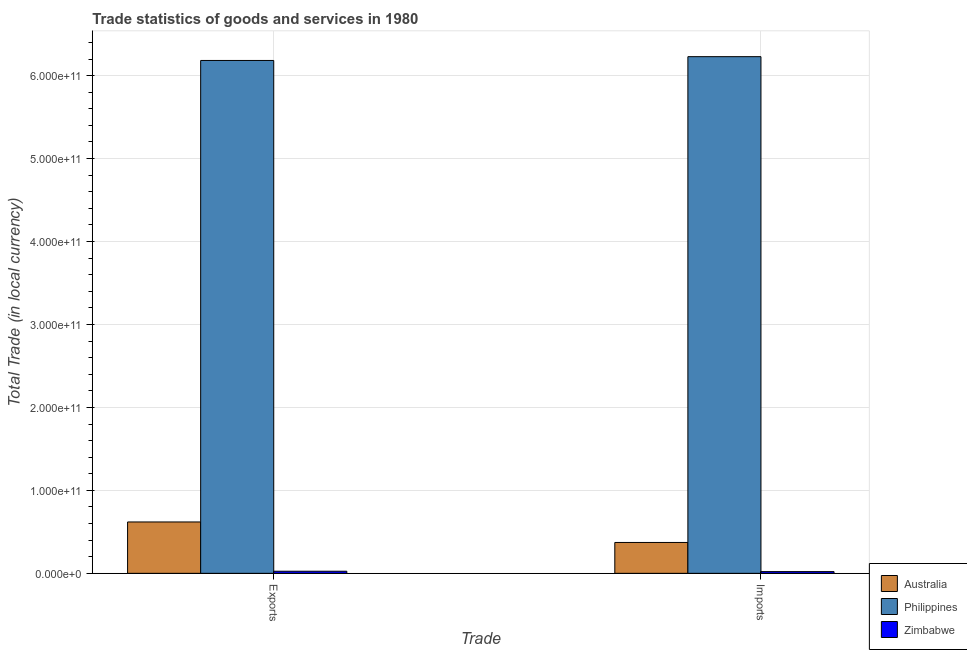How many different coloured bars are there?
Your response must be concise. 3. Are the number of bars per tick equal to the number of legend labels?
Offer a very short reply. Yes. What is the label of the 2nd group of bars from the left?
Make the answer very short. Imports. What is the export of goods and services in Australia?
Make the answer very short. 6.19e+1. Across all countries, what is the maximum imports of goods and services?
Offer a terse response. 6.23e+11. Across all countries, what is the minimum imports of goods and services?
Your answer should be compact. 2.06e+09. In which country was the imports of goods and services minimum?
Ensure brevity in your answer.  Zimbabwe. What is the total export of goods and services in the graph?
Your response must be concise. 6.83e+11. What is the difference between the imports of goods and services in Philippines and that in Zimbabwe?
Ensure brevity in your answer.  6.21e+11. What is the difference between the imports of goods and services in Philippines and the export of goods and services in Australia?
Provide a short and direct response. 5.61e+11. What is the average imports of goods and services per country?
Your response must be concise. 2.21e+11. What is the difference between the export of goods and services and imports of goods and services in Philippines?
Keep it short and to the point. -4.58e+09. What is the ratio of the imports of goods and services in Australia to that in Philippines?
Ensure brevity in your answer.  0.06. What does the 2nd bar from the right in Exports represents?
Your answer should be compact. Philippines. How many bars are there?
Make the answer very short. 6. What is the difference between two consecutive major ticks on the Y-axis?
Make the answer very short. 1.00e+11. Are the values on the major ticks of Y-axis written in scientific E-notation?
Keep it short and to the point. Yes. Does the graph contain any zero values?
Provide a short and direct response. No. Where does the legend appear in the graph?
Ensure brevity in your answer.  Bottom right. How many legend labels are there?
Provide a succinct answer. 3. What is the title of the graph?
Your response must be concise. Trade statistics of goods and services in 1980. Does "Iran" appear as one of the legend labels in the graph?
Offer a terse response. No. What is the label or title of the X-axis?
Ensure brevity in your answer.  Trade. What is the label or title of the Y-axis?
Make the answer very short. Total Trade (in local currency). What is the Total Trade (in local currency) in Australia in Exports?
Offer a terse response. 6.19e+1. What is the Total Trade (in local currency) of Philippines in Exports?
Provide a short and direct response. 6.18e+11. What is the Total Trade (in local currency) in Zimbabwe in Exports?
Provide a succinct answer. 2.54e+09. What is the Total Trade (in local currency) in Australia in Imports?
Your response must be concise. 3.72e+1. What is the Total Trade (in local currency) in Philippines in Imports?
Ensure brevity in your answer.  6.23e+11. What is the Total Trade (in local currency) in Zimbabwe in Imports?
Give a very brief answer. 2.06e+09. Across all Trade, what is the maximum Total Trade (in local currency) in Australia?
Offer a terse response. 6.19e+1. Across all Trade, what is the maximum Total Trade (in local currency) of Philippines?
Provide a short and direct response. 6.23e+11. Across all Trade, what is the maximum Total Trade (in local currency) in Zimbabwe?
Offer a very short reply. 2.54e+09. Across all Trade, what is the minimum Total Trade (in local currency) of Australia?
Your response must be concise. 3.72e+1. Across all Trade, what is the minimum Total Trade (in local currency) in Philippines?
Offer a terse response. 6.18e+11. Across all Trade, what is the minimum Total Trade (in local currency) of Zimbabwe?
Offer a very short reply. 2.06e+09. What is the total Total Trade (in local currency) of Australia in the graph?
Give a very brief answer. 9.92e+1. What is the total Total Trade (in local currency) in Philippines in the graph?
Your answer should be compact. 1.24e+12. What is the total Total Trade (in local currency) of Zimbabwe in the graph?
Give a very brief answer. 4.60e+09. What is the difference between the Total Trade (in local currency) of Australia in Exports and that in Imports?
Provide a short and direct response. 2.47e+1. What is the difference between the Total Trade (in local currency) in Philippines in Exports and that in Imports?
Offer a terse response. -4.58e+09. What is the difference between the Total Trade (in local currency) of Zimbabwe in Exports and that in Imports?
Your response must be concise. 4.75e+08. What is the difference between the Total Trade (in local currency) of Australia in Exports and the Total Trade (in local currency) of Philippines in Imports?
Keep it short and to the point. -5.61e+11. What is the difference between the Total Trade (in local currency) in Australia in Exports and the Total Trade (in local currency) in Zimbabwe in Imports?
Ensure brevity in your answer.  5.99e+1. What is the difference between the Total Trade (in local currency) of Philippines in Exports and the Total Trade (in local currency) of Zimbabwe in Imports?
Ensure brevity in your answer.  6.16e+11. What is the average Total Trade (in local currency) of Australia per Trade?
Provide a succinct answer. 4.96e+1. What is the average Total Trade (in local currency) of Philippines per Trade?
Give a very brief answer. 6.21e+11. What is the average Total Trade (in local currency) of Zimbabwe per Trade?
Make the answer very short. 2.30e+09. What is the difference between the Total Trade (in local currency) of Australia and Total Trade (in local currency) of Philippines in Exports?
Provide a short and direct response. -5.56e+11. What is the difference between the Total Trade (in local currency) of Australia and Total Trade (in local currency) of Zimbabwe in Exports?
Make the answer very short. 5.94e+1. What is the difference between the Total Trade (in local currency) of Philippines and Total Trade (in local currency) of Zimbabwe in Exports?
Keep it short and to the point. 6.16e+11. What is the difference between the Total Trade (in local currency) of Australia and Total Trade (in local currency) of Philippines in Imports?
Provide a succinct answer. -5.86e+11. What is the difference between the Total Trade (in local currency) of Australia and Total Trade (in local currency) of Zimbabwe in Imports?
Offer a terse response. 3.52e+1. What is the difference between the Total Trade (in local currency) in Philippines and Total Trade (in local currency) in Zimbabwe in Imports?
Offer a terse response. 6.21e+11. What is the ratio of the Total Trade (in local currency) of Australia in Exports to that in Imports?
Your answer should be very brief. 1.66. What is the ratio of the Total Trade (in local currency) in Zimbabwe in Exports to that in Imports?
Keep it short and to the point. 1.23. What is the difference between the highest and the second highest Total Trade (in local currency) of Australia?
Give a very brief answer. 2.47e+1. What is the difference between the highest and the second highest Total Trade (in local currency) of Philippines?
Your answer should be very brief. 4.58e+09. What is the difference between the highest and the second highest Total Trade (in local currency) in Zimbabwe?
Your answer should be very brief. 4.75e+08. What is the difference between the highest and the lowest Total Trade (in local currency) in Australia?
Provide a short and direct response. 2.47e+1. What is the difference between the highest and the lowest Total Trade (in local currency) in Philippines?
Make the answer very short. 4.58e+09. What is the difference between the highest and the lowest Total Trade (in local currency) in Zimbabwe?
Offer a terse response. 4.75e+08. 